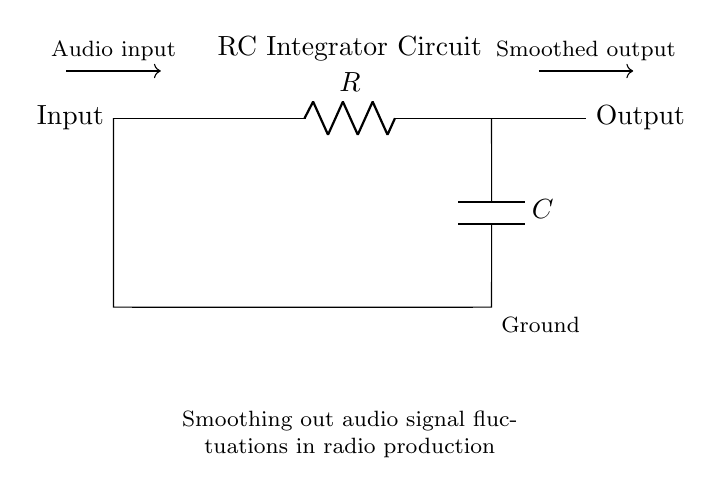What are the components used in this circuit? The circuit contains a resistor and a capacitor labeled R and C, respectively. These components can be identified in the diagram by their symbols and labels.
Answer: Resistor and Capacitor What is the purpose of the circuit? The circuit is designed to smooth out audio signal fluctuations, indicated by the label describing its function beneath the circuit.
Answer: Smoothing audio signals What type of circuit is this? This is an RC integrator circuit, recognized by the presence of a resistor and capacitor arranged to perform integration on an input signal.
Answer: RC integrator Which direction does the audio input flow? The audio input flows from left to right, as denoted by the arrow indicating the direction of the current from the input to the output.
Answer: Left to right What happens to the output signal compared to the input signal? The output signal is smoothed compared to the input signal, as indicated by the label for the output being described as "smoothed."
Answer: Smoothed What is at the output of the circuit? The output of the circuit consists of a smoothed output signal, shown on the right side of the circuit with an arrow pointing towards it.
Answer: Smoothed output What is the function of the capacitor in this circuit? The capacitor in this circuit helps to filter and smooth the voltage changes over time, effectively integrating the input signal to produce a more stable output.
Answer: Filter voltage changes 